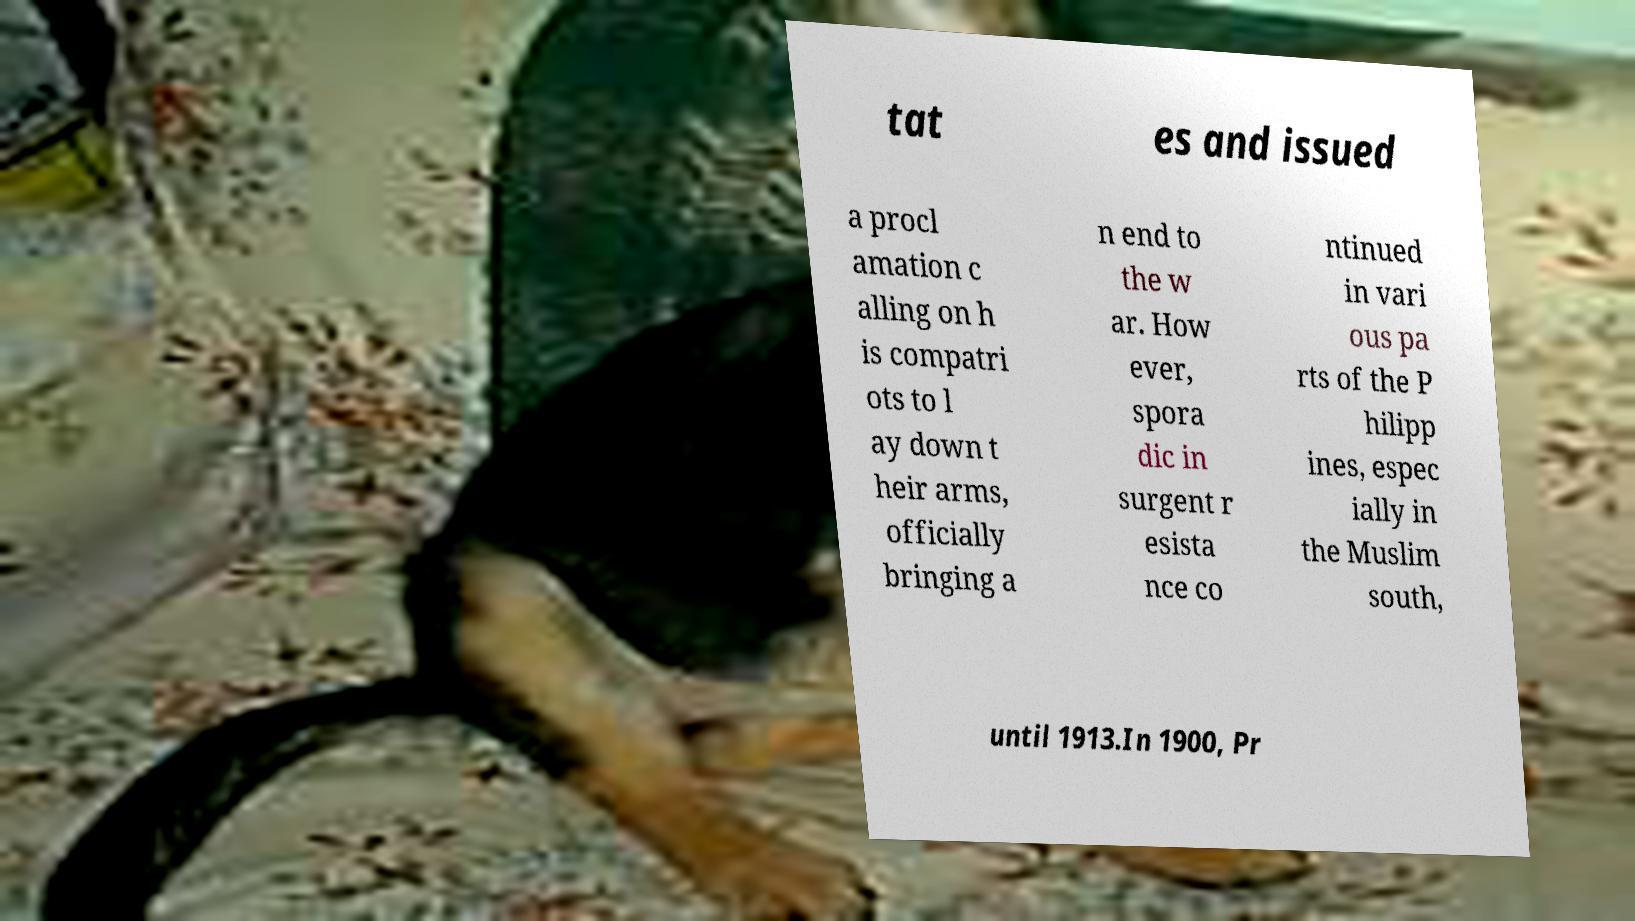For documentation purposes, I need the text within this image transcribed. Could you provide that? tat es and issued a procl amation c alling on h is compatri ots to l ay down t heir arms, officially bringing a n end to the w ar. How ever, spora dic in surgent r esista nce co ntinued in vari ous pa rts of the P hilipp ines, espec ially in the Muslim south, until 1913.In 1900, Pr 